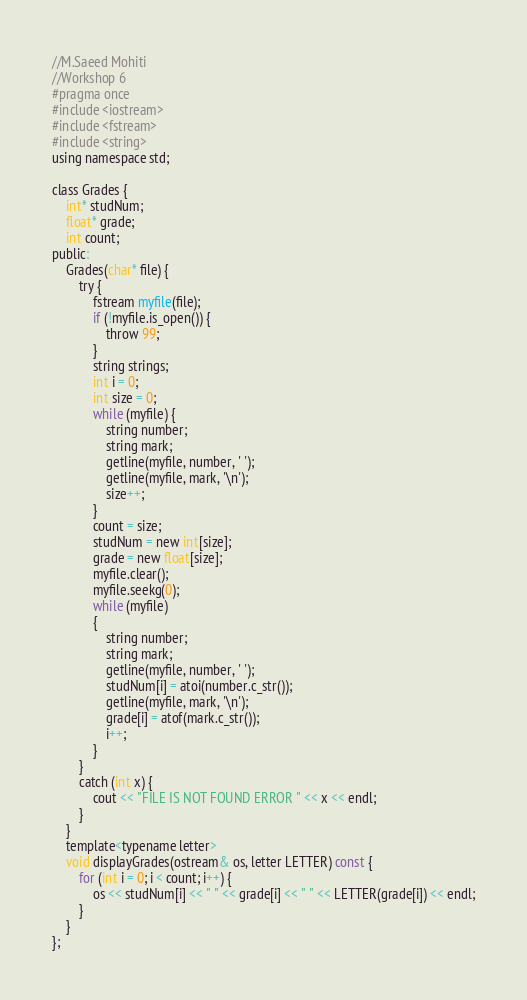<code> <loc_0><loc_0><loc_500><loc_500><_C_>//M.Saeed Mohiti
//Workshop 6
#pragma once
#include <iostream>
#include <fstream>
#include <string>
using namespace std;

class Grades {
	int* studNum;
	float* grade;
	int count;
public:
	Grades(char* file) {
		try {
			fstream myfile(file);
			if (!myfile.is_open()) {
				throw 99;
			}
			string strings;
			int i = 0;
			int size = 0;
			while (myfile) {
				string number;
				string mark;
				getline(myfile, number, ' ');
				getline(myfile, mark, '\n');
				size++;
			}
			count = size;
			studNum = new int[size];
			grade = new float[size];
			myfile.clear();
			myfile.seekg(0);
			while (myfile)
			{
				string number;
				string mark;
				getline(myfile, number, ' ');
				studNum[i] = atoi(number.c_str());
				getline(myfile, mark, '\n');
				grade[i] = atof(mark.c_str());
				i++;
			}
		}
		catch (int x) {
			cout << "FILE IS NOT FOUND ERROR " << x << endl;
		}
	}
	template<typename letter>
	void displayGrades(ostream& os, letter LETTER) const {
		for (int i = 0; i < count; i++) {
			os << studNum[i] << " " << grade[i] << " " << LETTER(grade[i]) << endl;
		}
	}
};</code> 